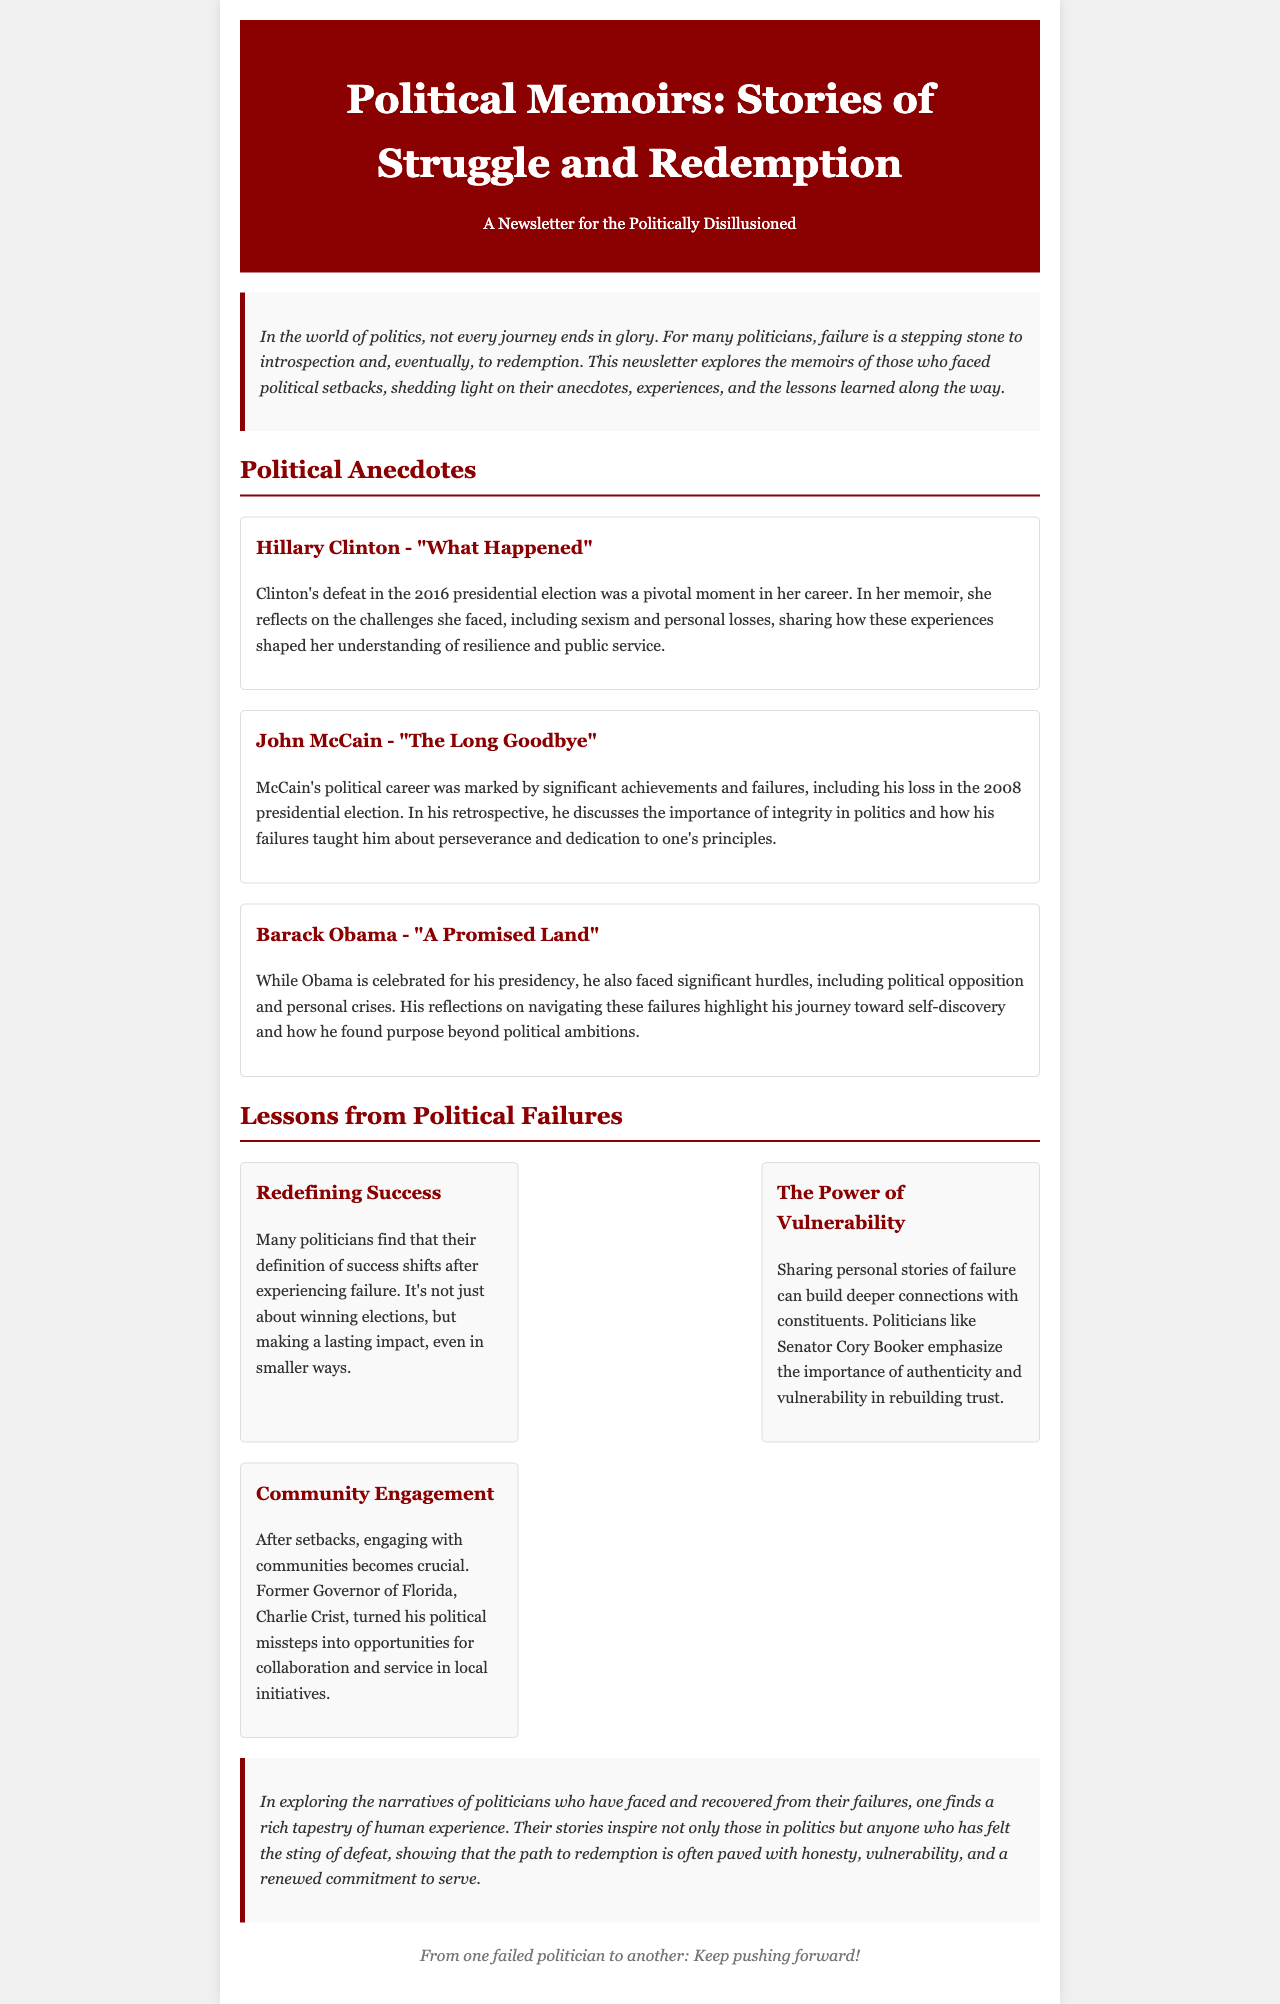what is the title of the newsletter? The title of the newsletter is presented at the beginning of the document.
Answer: Political Memoirs: Stories of Struggle and Redemption who is the author of the memoir "What Happened"? The document mentions Hillary Clinton in connection with the memoir.
Answer: Hillary Clinton what year did John McCain lose the presidential election? The document specifies the event related to the presidential election loss.
Answer: 2008 what is one lesson learned from political failures? The newsletter outlines lessons derived from political experiences.
Answer: Redefining Success which former governor turned political missteps into opportunities for service? The document refers specifically to a former governor's actions after failure.
Answer: Charlie Crist what theme is emphasized by Senator Cory Booker? The document highlights the message conveyed by various politicians.
Answer: The Power of Vulnerability who reflects on their presidency and journey toward self-discovery? The memoir discussed in the document pertains to a notable figure's reflections.
Answer: Barack Obama how do many politicians redefine success after failure? The document describes how politicians view success differently post-failure.
Answer: Making a lasting impact 